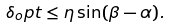<formula> <loc_0><loc_0><loc_500><loc_500>\delta _ { o } p t \leq \eta \sin ( \beta - \alpha ) .</formula> 